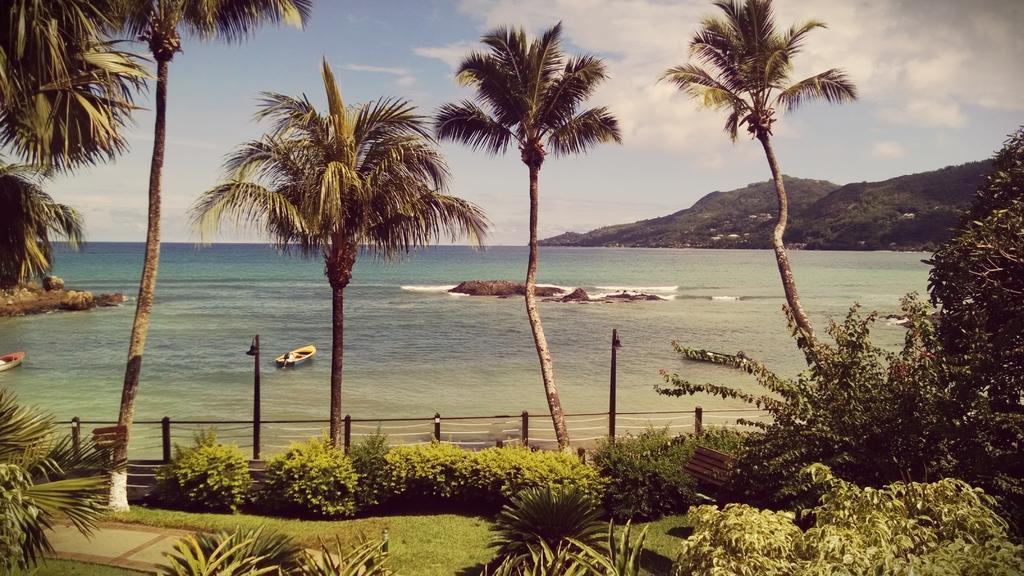How would you summarize this image in a sentence or two? In this image, we can see so many trees, plants, grass, walkway, poles, fencing. In the middle, we can see the sea, boat and mountains. Background there is a sky. 